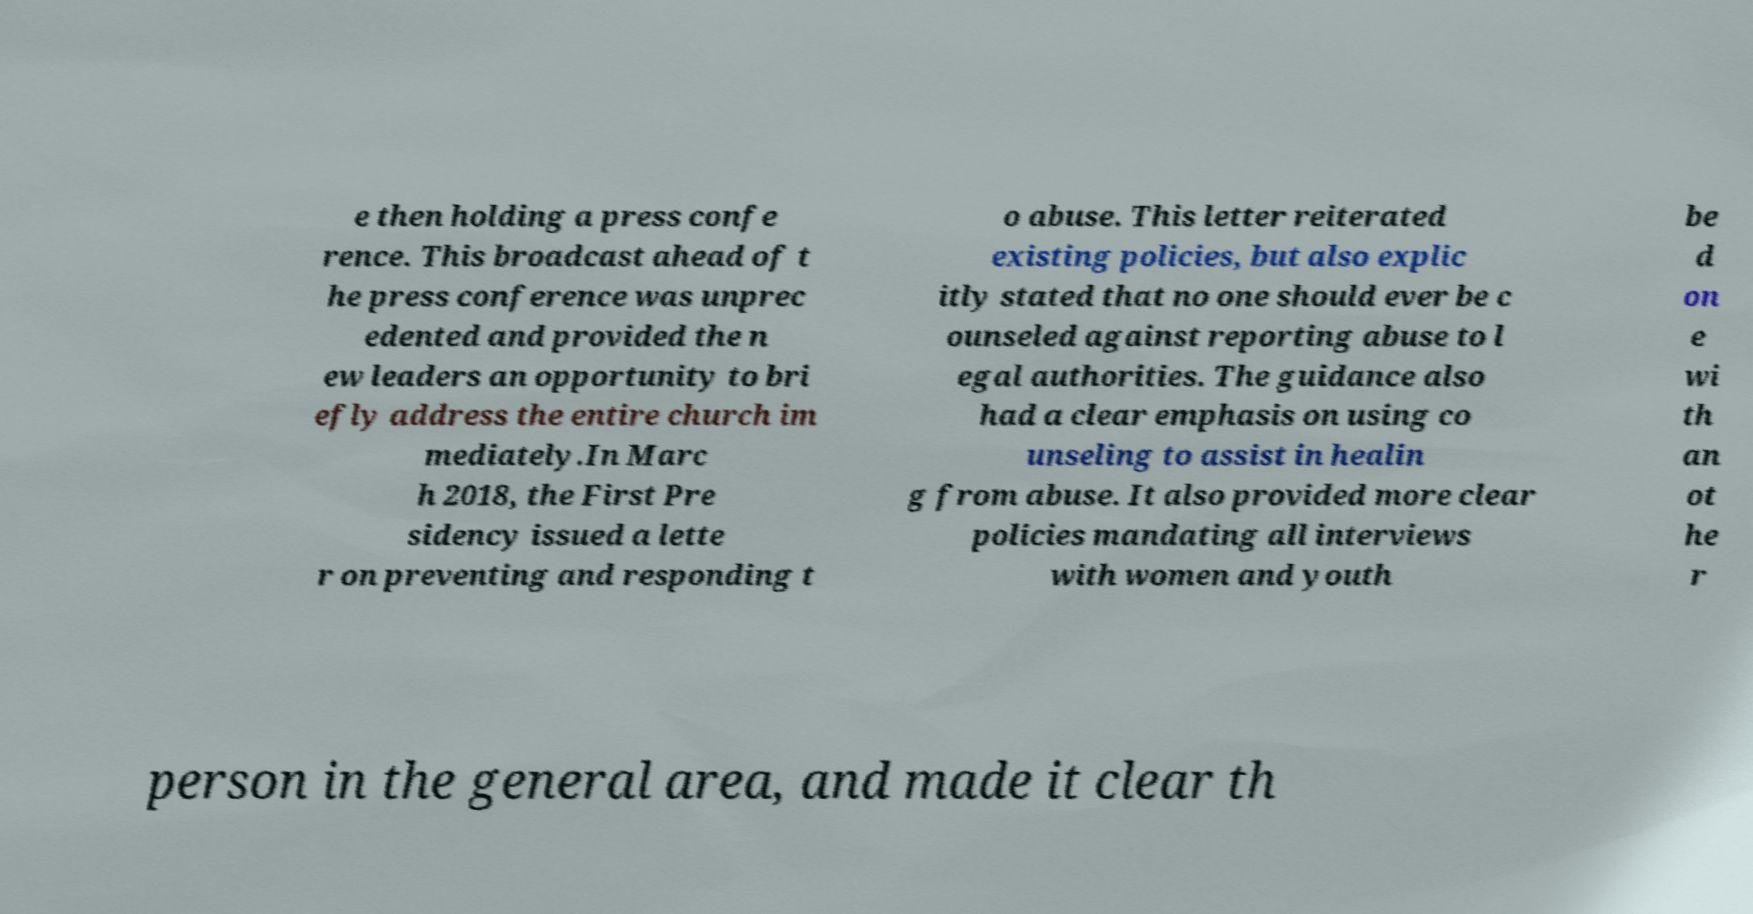Can you accurately transcribe the text from the provided image for me? e then holding a press confe rence. This broadcast ahead of t he press conference was unprec edented and provided the n ew leaders an opportunity to bri efly address the entire church im mediately.In Marc h 2018, the First Pre sidency issued a lette r on preventing and responding t o abuse. This letter reiterated existing policies, but also explic itly stated that no one should ever be c ounseled against reporting abuse to l egal authorities. The guidance also had a clear emphasis on using co unseling to assist in healin g from abuse. It also provided more clear policies mandating all interviews with women and youth be d on e wi th an ot he r person in the general area, and made it clear th 